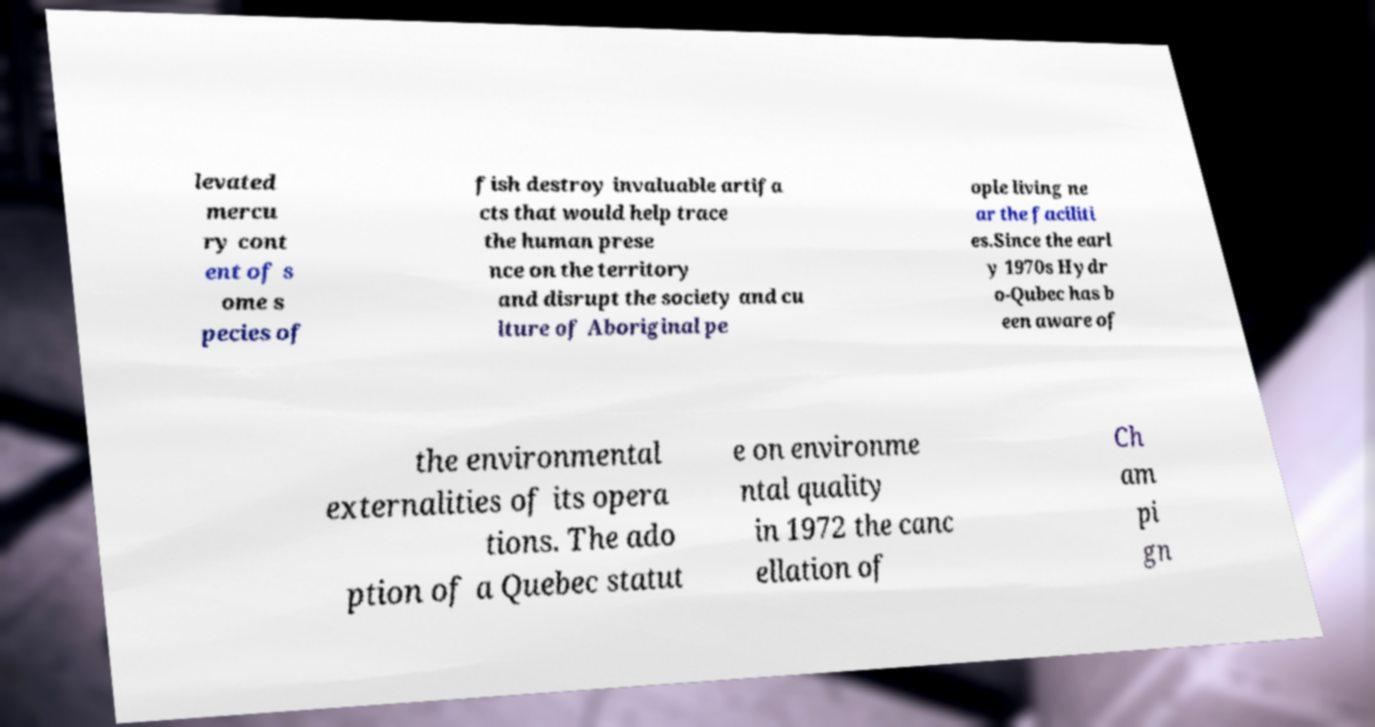I need the written content from this picture converted into text. Can you do that? levated mercu ry cont ent of s ome s pecies of fish destroy invaluable artifa cts that would help trace the human prese nce on the territory and disrupt the society and cu lture of Aboriginal pe ople living ne ar the faciliti es.Since the earl y 1970s Hydr o-Qubec has b een aware of the environmental externalities of its opera tions. The ado ption of a Quebec statut e on environme ntal quality in 1972 the canc ellation of Ch am pi gn 